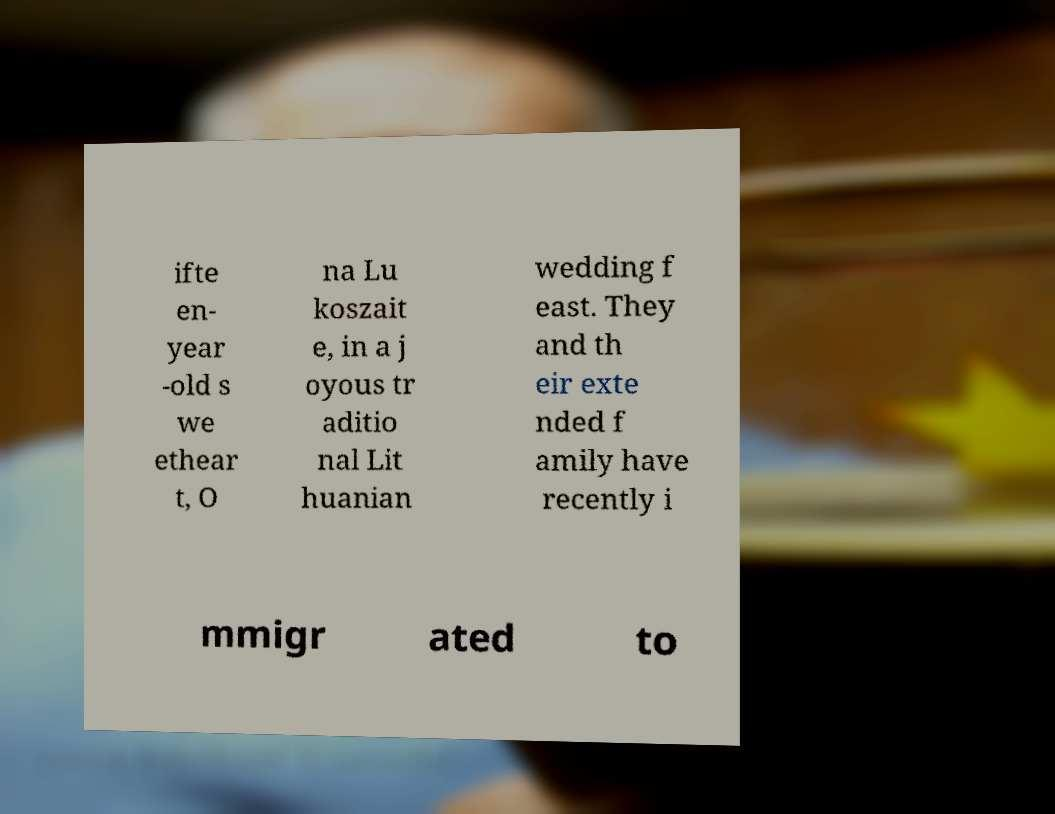Please identify and transcribe the text found in this image. ifte en- year -old s we ethear t, O na Lu koszait e, in a j oyous tr aditio nal Lit huanian wedding f east. They and th eir exte nded f amily have recently i mmigr ated to 